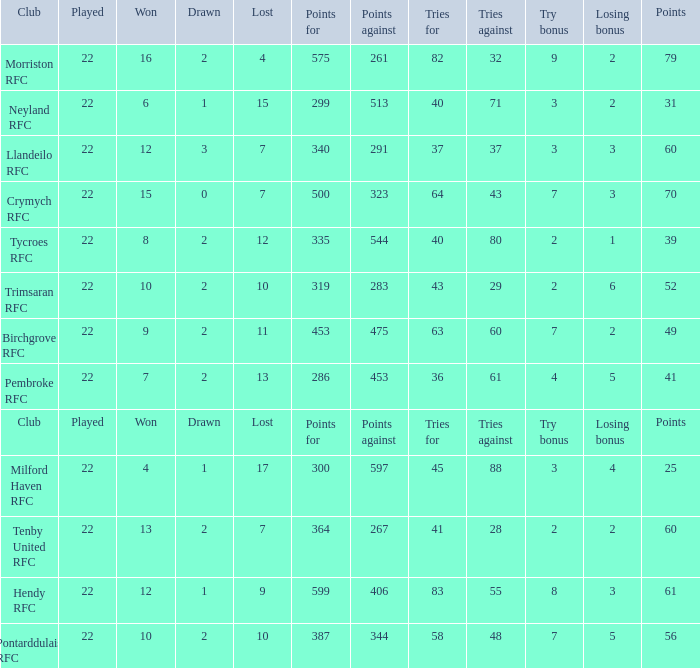What's the club with losing bonus being 1 Tycroes RFC. 